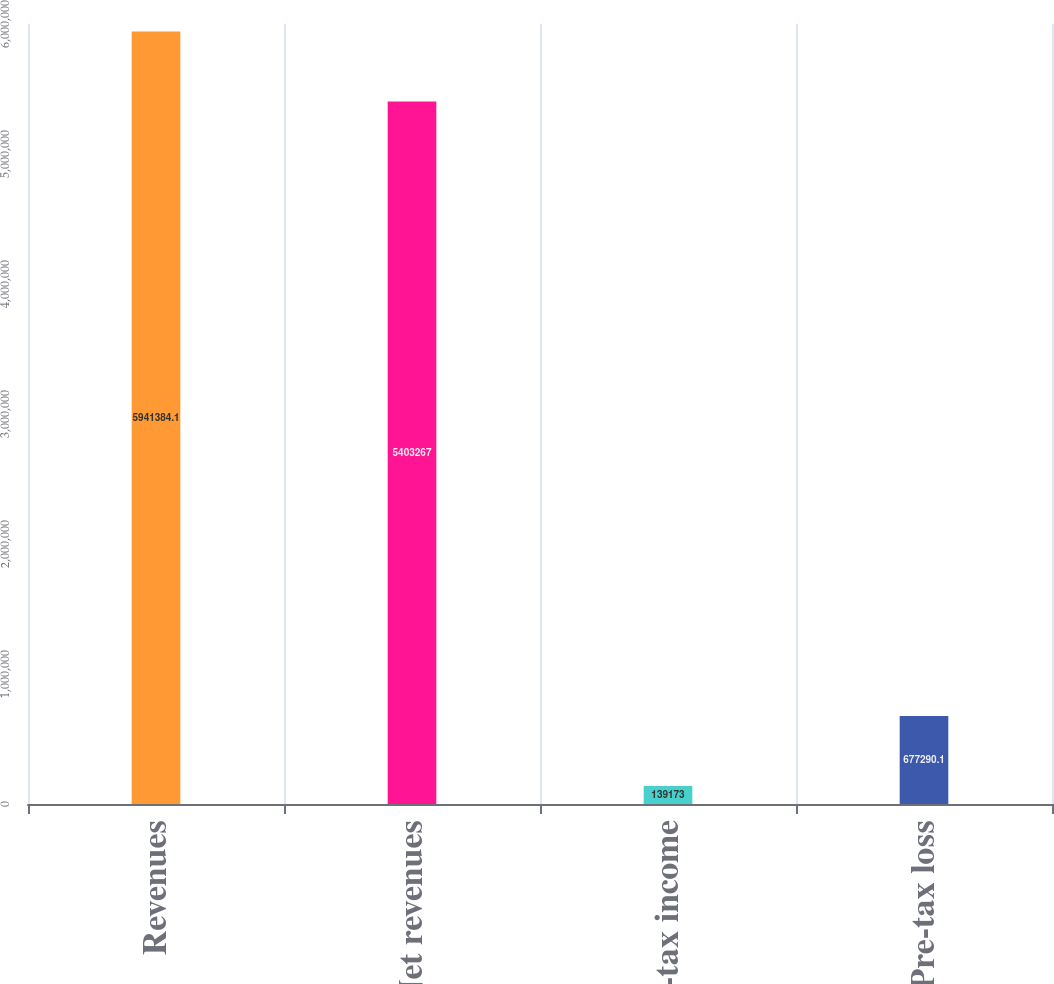Convert chart to OTSL. <chart><loc_0><loc_0><loc_500><loc_500><bar_chart><fcel>Revenues<fcel>Net revenues<fcel>Pre-tax income<fcel>Pre-tax loss<nl><fcel>5.94138e+06<fcel>5.40327e+06<fcel>139173<fcel>677290<nl></chart> 